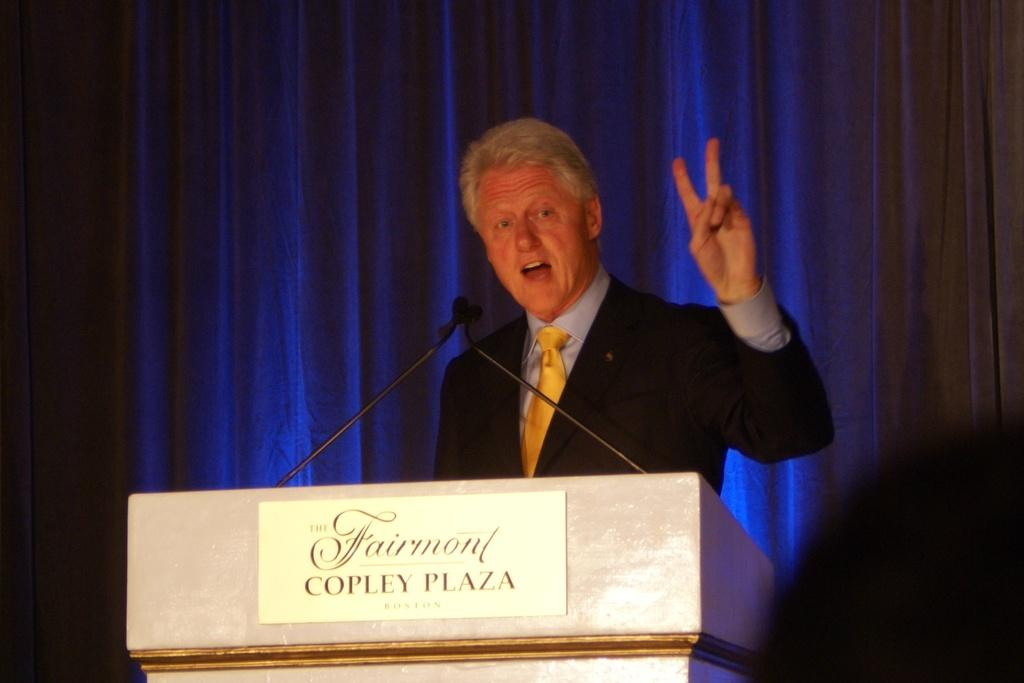<image>
Write a terse but informative summary of the picture. Bill Clinton at a podium that reads Fairmont Copley Plaza. 